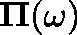Convert formula to latex. <formula><loc_0><loc_0><loc_500><loc_500>\Pi ( \omega )</formula> 